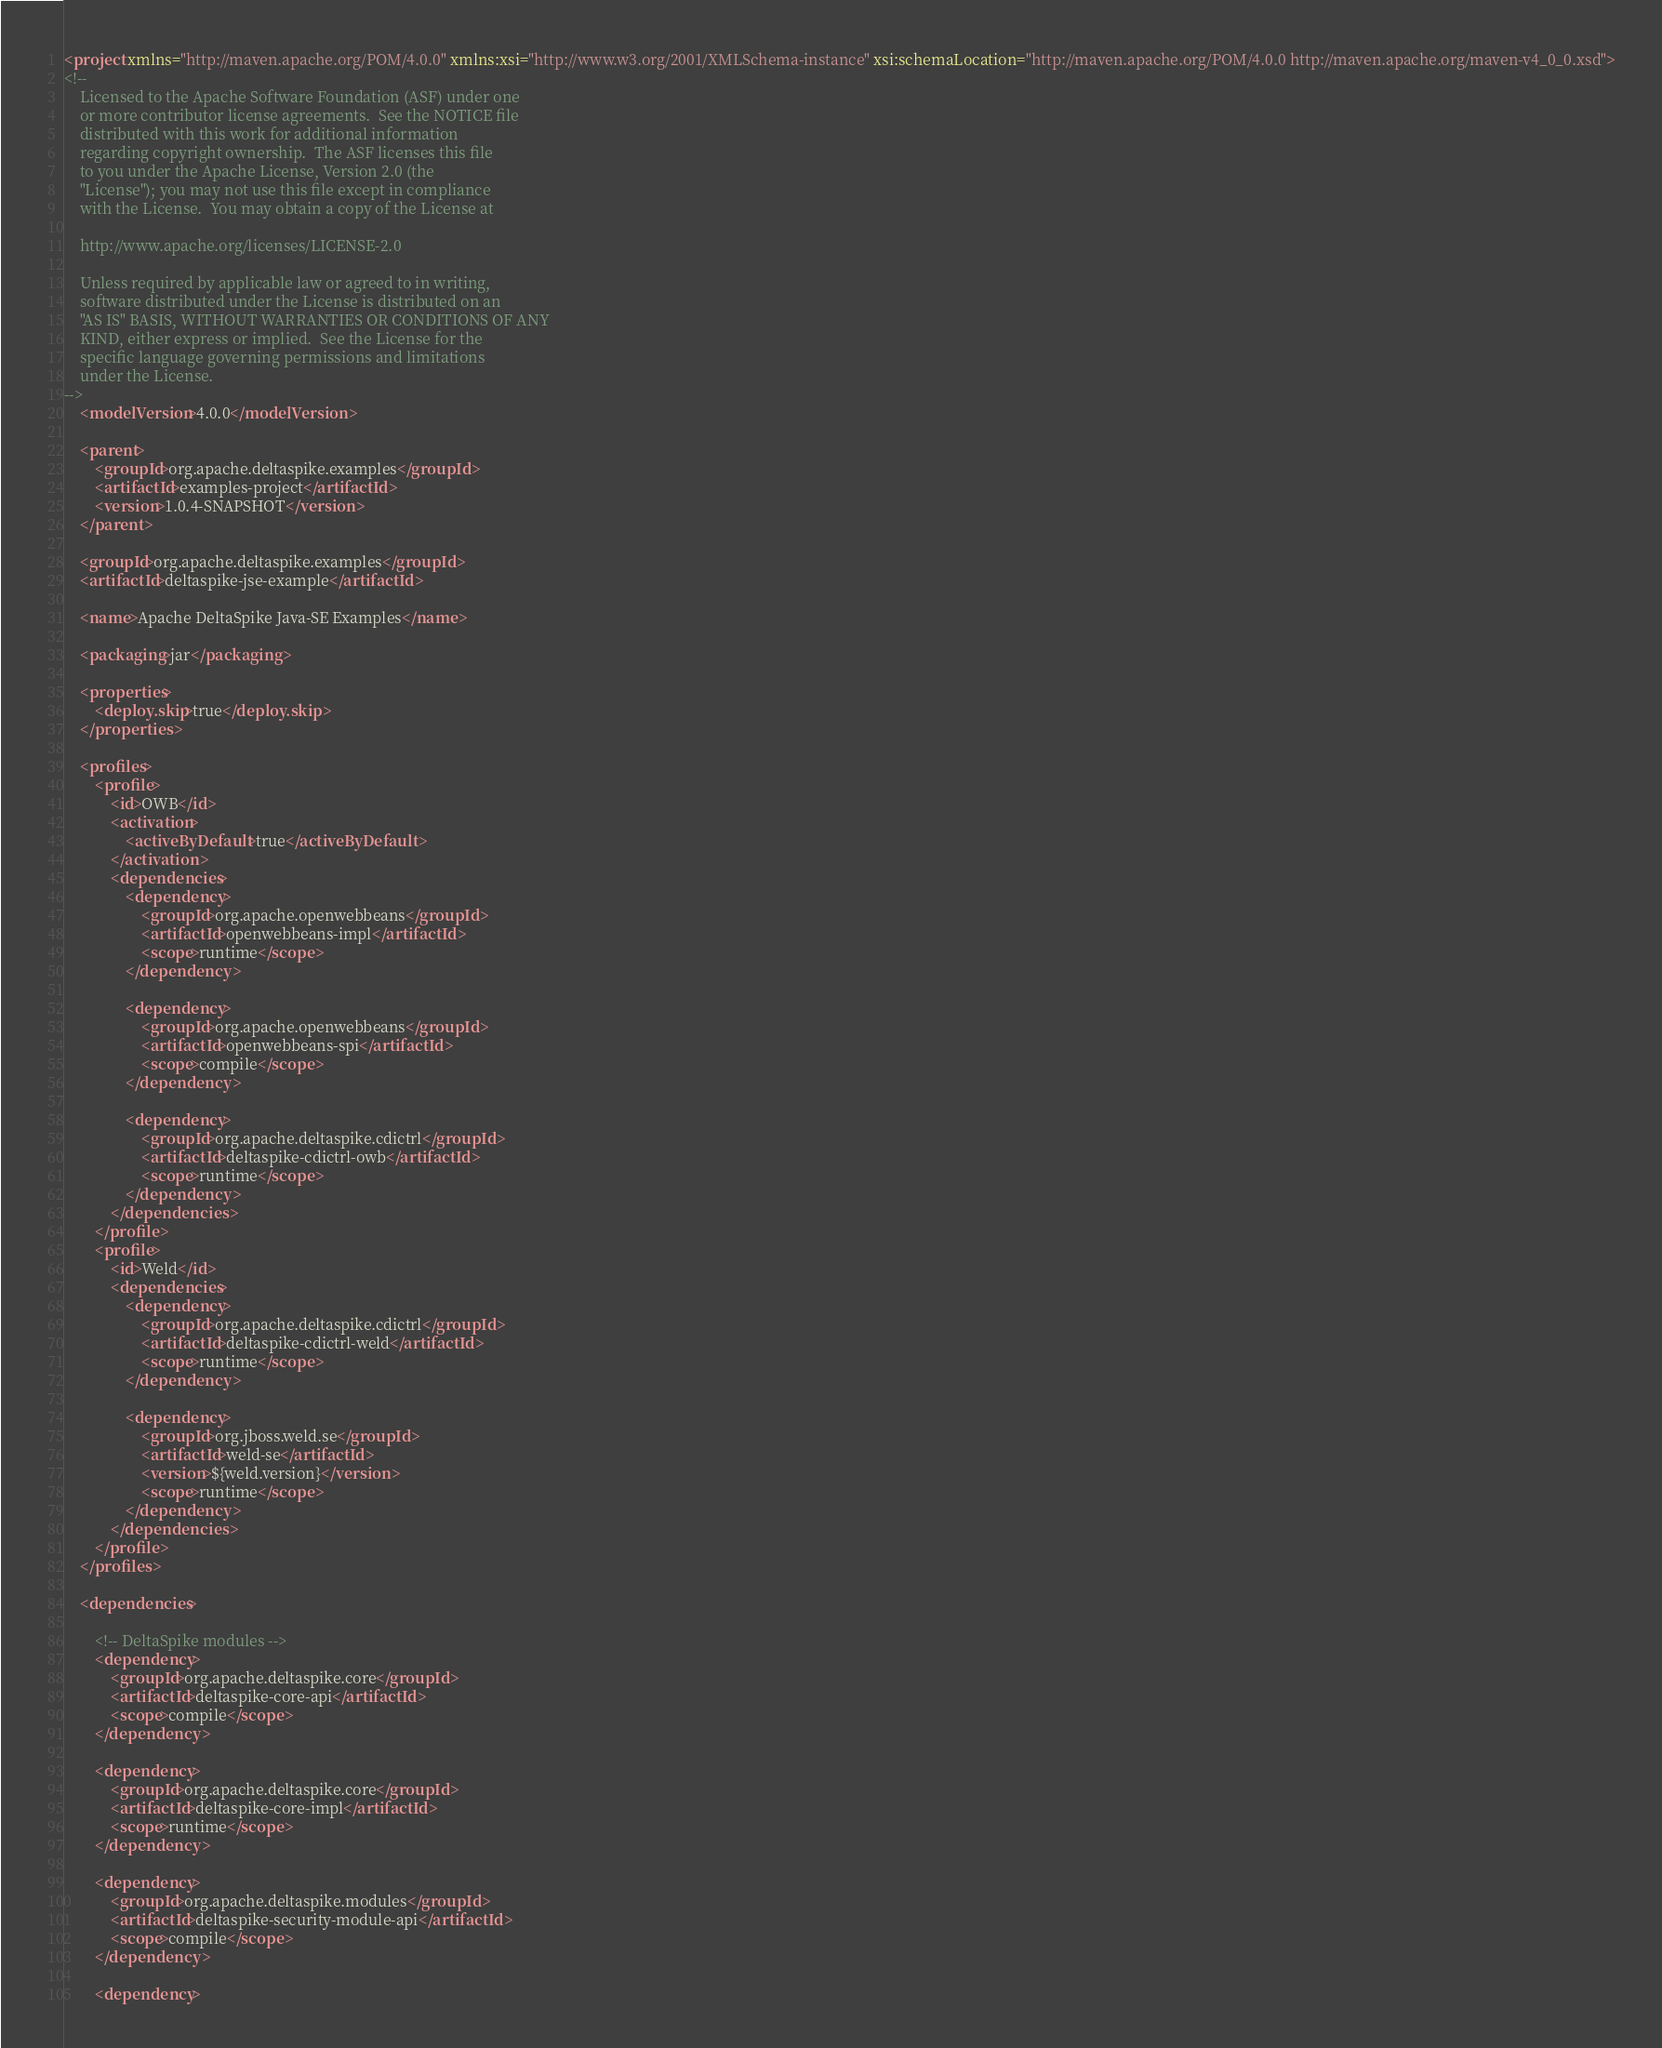Convert code to text. <code><loc_0><loc_0><loc_500><loc_500><_XML_><project xmlns="http://maven.apache.org/POM/4.0.0" xmlns:xsi="http://www.w3.org/2001/XMLSchema-instance" xsi:schemaLocation="http://maven.apache.org/POM/4.0.0 http://maven.apache.org/maven-v4_0_0.xsd">
<!--
    Licensed to the Apache Software Foundation (ASF) under one
    or more contributor license agreements.  See the NOTICE file
    distributed with this work for additional information
    regarding copyright ownership.  The ASF licenses this file
    to you under the Apache License, Version 2.0 (the
    "License"); you may not use this file except in compliance
    with the License.  You may obtain a copy of the License at

    http://www.apache.org/licenses/LICENSE-2.0

    Unless required by applicable law or agreed to in writing,
    software distributed under the License is distributed on an
    "AS IS" BASIS, WITHOUT WARRANTIES OR CONDITIONS OF ANY
    KIND, either express or implied.  See the License for the
    specific language governing permissions and limitations
    under the License.
-->
    <modelVersion>4.0.0</modelVersion>

    <parent>
        <groupId>org.apache.deltaspike.examples</groupId>
        <artifactId>examples-project</artifactId>
        <version>1.0.4-SNAPSHOT</version>
    </parent>

    <groupId>org.apache.deltaspike.examples</groupId>
    <artifactId>deltaspike-jse-example</artifactId>

    <name>Apache DeltaSpike Java-SE Examples</name>

    <packaging>jar</packaging>

    <properties>
        <deploy.skip>true</deploy.skip>
    </properties>

    <profiles>
        <profile>
            <id>OWB</id>
            <activation>
                <activeByDefault>true</activeByDefault>
            </activation>
            <dependencies>
                <dependency>
                    <groupId>org.apache.openwebbeans</groupId>
                    <artifactId>openwebbeans-impl</artifactId>
                    <scope>runtime</scope>
                </dependency>

                <dependency>
                    <groupId>org.apache.openwebbeans</groupId>
                    <artifactId>openwebbeans-spi</artifactId>
                    <scope>compile</scope>
                </dependency>

                <dependency>
                    <groupId>org.apache.deltaspike.cdictrl</groupId>
                    <artifactId>deltaspike-cdictrl-owb</artifactId>
                    <scope>runtime</scope>
                </dependency>
            </dependencies>
        </profile>
        <profile>
            <id>Weld</id>
            <dependencies>
                <dependency>
                    <groupId>org.apache.deltaspike.cdictrl</groupId>
                    <artifactId>deltaspike-cdictrl-weld</artifactId>
                    <scope>runtime</scope>
                </dependency>

                <dependency>
                    <groupId>org.jboss.weld.se</groupId>
                    <artifactId>weld-se</artifactId>
                    <version>${weld.version}</version>
                    <scope>runtime</scope>
                </dependency>
            </dependencies>
        </profile>
    </profiles>

    <dependencies>

        <!-- DeltaSpike modules -->
        <dependency>
            <groupId>org.apache.deltaspike.core</groupId>
            <artifactId>deltaspike-core-api</artifactId>
            <scope>compile</scope>
        </dependency>

        <dependency>
            <groupId>org.apache.deltaspike.core</groupId>
            <artifactId>deltaspike-core-impl</artifactId>
            <scope>runtime</scope>
        </dependency>

        <dependency>
            <groupId>org.apache.deltaspike.modules</groupId>
            <artifactId>deltaspike-security-module-api</artifactId>
            <scope>compile</scope>
        </dependency>

        <dependency></code> 